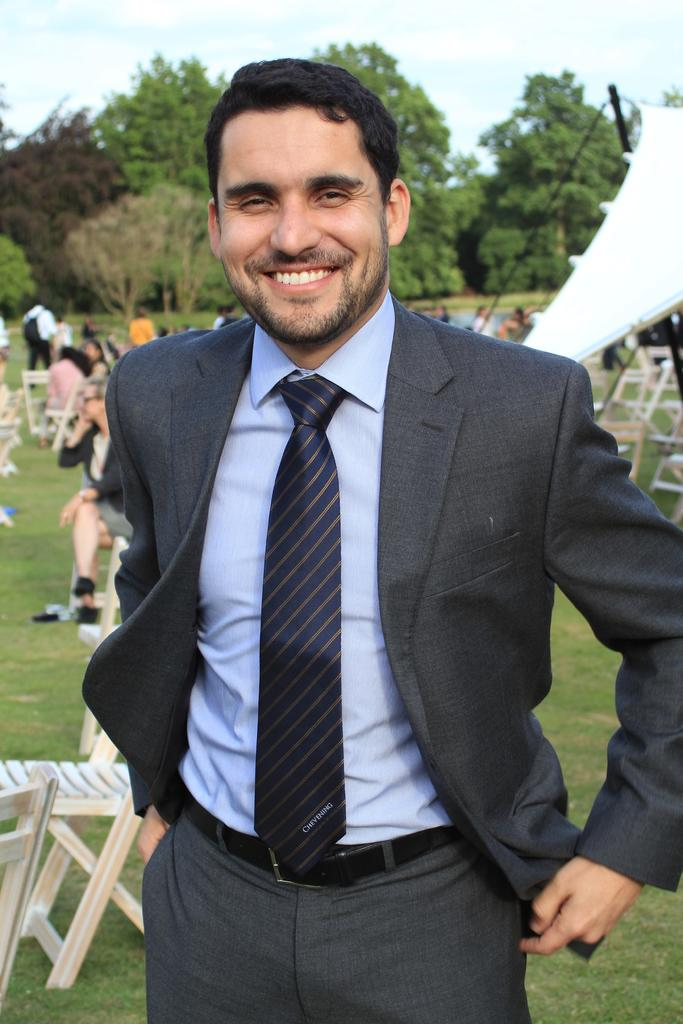What is the person in the image doing? The person in the image is standing and smiling. What objects are present in the image that people might sit on? There are chairs visible in the image. How many other persons are in the image besides the person standing and smiling? There are other persons in the image. What type of natural environment can be seen in the image? There are trees in the image. What is visible in the background of the image? The sky is visible in the image. What type of shelter is present in the image? There is a tent in the image. What type of jam is being spread on the calculator in the image? There is no jam or calculator present in the image. 